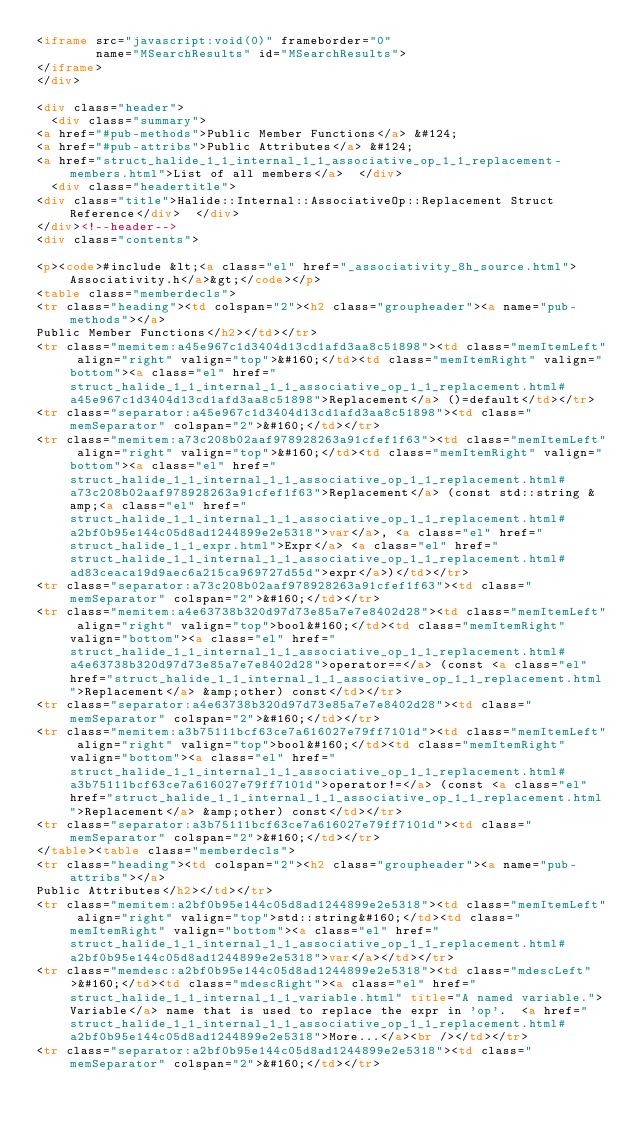<code> <loc_0><loc_0><loc_500><loc_500><_HTML_><iframe src="javascript:void(0)" frameborder="0" 
        name="MSearchResults" id="MSearchResults">
</iframe>
</div>

<div class="header">
  <div class="summary">
<a href="#pub-methods">Public Member Functions</a> &#124;
<a href="#pub-attribs">Public Attributes</a> &#124;
<a href="struct_halide_1_1_internal_1_1_associative_op_1_1_replacement-members.html">List of all members</a>  </div>
  <div class="headertitle">
<div class="title">Halide::Internal::AssociativeOp::Replacement Struct Reference</div>  </div>
</div><!--header-->
<div class="contents">

<p><code>#include &lt;<a class="el" href="_associativity_8h_source.html">Associativity.h</a>&gt;</code></p>
<table class="memberdecls">
<tr class="heading"><td colspan="2"><h2 class="groupheader"><a name="pub-methods"></a>
Public Member Functions</h2></td></tr>
<tr class="memitem:a45e967c1d3404d13cd1afd3aa8c51898"><td class="memItemLeft" align="right" valign="top">&#160;</td><td class="memItemRight" valign="bottom"><a class="el" href="struct_halide_1_1_internal_1_1_associative_op_1_1_replacement.html#a45e967c1d3404d13cd1afd3aa8c51898">Replacement</a> ()=default</td></tr>
<tr class="separator:a45e967c1d3404d13cd1afd3aa8c51898"><td class="memSeparator" colspan="2">&#160;</td></tr>
<tr class="memitem:a73c208b02aaf978928263a91cfef1f63"><td class="memItemLeft" align="right" valign="top">&#160;</td><td class="memItemRight" valign="bottom"><a class="el" href="struct_halide_1_1_internal_1_1_associative_op_1_1_replacement.html#a73c208b02aaf978928263a91cfef1f63">Replacement</a> (const std::string &amp;<a class="el" href="struct_halide_1_1_internal_1_1_associative_op_1_1_replacement.html#a2bf0b95e144c05d8ad1244899e2e5318">var</a>, <a class="el" href="struct_halide_1_1_expr.html">Expr</a> <a class="el" href="struct_halide_1_1_internal_1_1_associative_op_1_1_replacement.html#ad83ceaca19d9aec6a215ca969727d55d">expr</a>)</td></tr>
<tr class="separator:a73c208b02aaf978928263a91cfef1f63"><td class="memSeparator" colspan="2">&#160;</td></tr>
<tr class="memitem:a4e63738b320d97d73e85a7e7e8402d28"><td class="memItemLeft" align="right" valign="top">bool&#160;</td><td class="memItemRight" valign="bottom"><a class="el" href="struct_halide_1_1_internal_1_1_associative_op_1_1_replacement.html#a4e63738b320d97d73e85a7e7e8402d28">operator==</a> (const <a class="el" href="struct_halide_1_1_internal_1_1_associative_op_1_1_replacement.html">Replacement</a> &amp;other) const</td></tr>
<tr class="separator:a4e63738b320d97d73e85a7e7e8402d28"><td class="memSeparator" colspan="2">&#160;</td></tr>
<tr class="memitem:a3b75111bcf63ce7a616027e79ff7101d"><td class="memItemLeft" align="right" valign="top">bool&#160;</td><td class="memItemRight" valign="bottom"><a class="el" href="struct_halide_1_1_internal_1_1_associative_op_1_1_replacement.html#a3b75111bcf63ce7a616027e79ff7101d">operator!=</a> (const <a class="el" href="struct_halide_1_1_internal_1_1_associative_op_1_1_replacement.html">Replacement</a> &amp;other) const</td></tr>
<tr class="separator:a3b75111bcf63ce7a616027e79ff7101d"><td class="memSeparator" colspan="2">&#160;</td></tr>
</table><table class="memberdecls">
<tr class="heading"><td colspan="2"><h2 class="groupheader"><a name="pub-attribs"></a>
Public Attributes</h2></td></tr>
<tr class="memitem:a2bf0b95e144c05d8ad1244899e2e5318"><td class="memItemLeft" align="right" valign="top">std::string&#160;</td><td class="memItemRight" valign="bottom"><a class="el" href="struct_halide_1_1_internal_1_1_associative_op_1_1_replacement.html#a2bf0b95e144c05d8ad1244899e2e5318">var</a></td></tr>
<tr class="memdesc:a2bf0b95e144c05d8ad1244899e2e5318"><td class="mdescLeft">&#160;</td><td class="mdescRight"><a class="el" href="struct_halide_1_1_internal_1_1_variable.html" title="A named variable.">Variable</a> name that is used to replace the expr in 'op'.  <a href="struct_halide_1_1_internal_1_1_associative_op_1_1_replacement.html#a2bf0b95e144c05d8ad1244899e2e5318">More...</a><br /></td></tr>
<tr class="separator:a2bf0b95e144c05d8ad1244899e2e5318"><td class="memSeparator" colspan="2">&#160;</td></tr></code> 